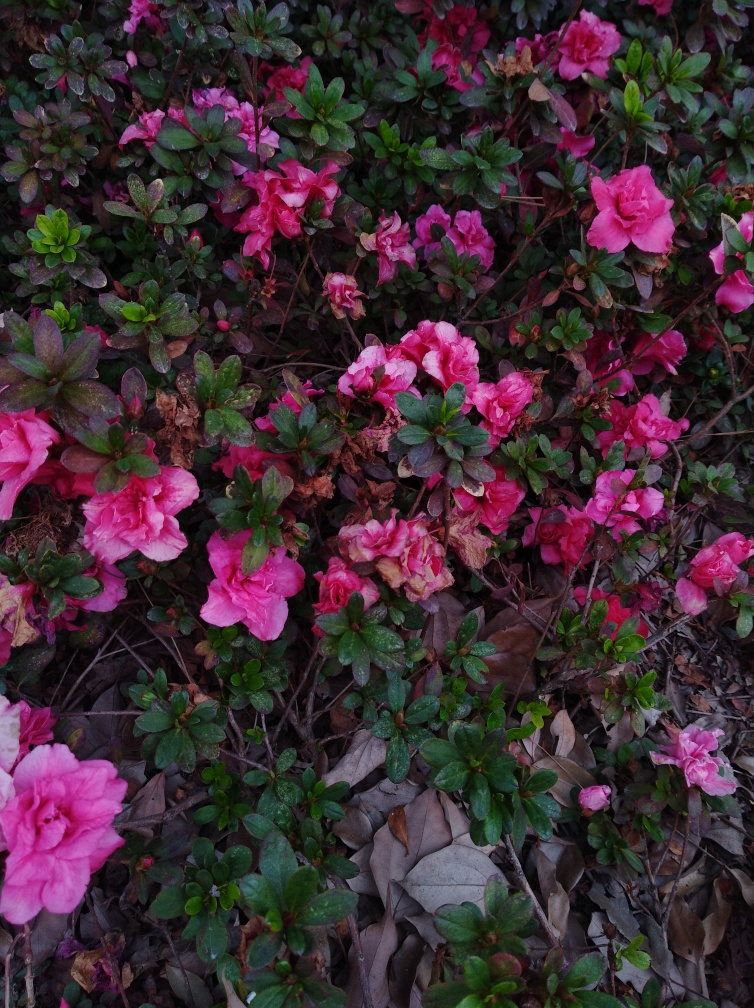Can you tell me about the health of these plants? From the image, it seems that some of the azaleas are healthy with vibrant flowers, but there are also signs of wilting and browning, indicating that some plants may be stressed or suffering from inadequate care or environmental factors. What could be the cause of the wilting and browning? The wilting and browning could be caused by a variety of factors, such as over or under-watering, pests, diseases like azalea lace bug, or even natural seasonal changes. It's important to assess the specific conditions affecting these plants to address the issue. 